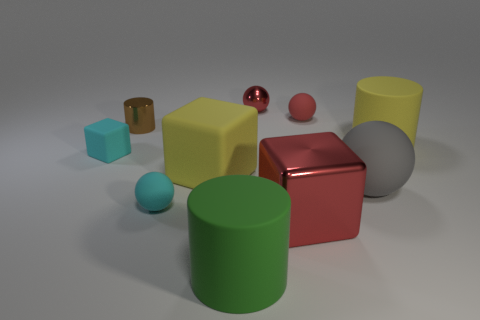There is a block that is left of the green cylinder and to the right of the cyan block; what material is it?
Give a very brief answer. Rubber. Is there anything else that is the same color as the tiny metallic ball?
Ensure brevity in your answer.  Yes. Is the number of tiny red rubber things that are to the right of the green rubber object less than the number of tiny blue shiny balls?
Keep it short and to the point. No. Is the number of cyan rubber things greater than the number of brown objects?
Keep it short and to the point. Yes. Are there any tiny red objects that are to the right of the tiny red metal thing behind the big matte cylinder that is on the right side of the big gray thing?
Ensure brevity in your answer.  Yes. How many other things are there of the same size as the cyan ball?
Your answer should be very brief. 4. There is a red metallic sphere; are there any yellow rubber objects behind it?
Offer a terse response. No. Do the tiny cube and the matte cylinder behind the green cylinder have the same color?
Provide a succinct answer. No. What color is the cylinder that is to the right of the tiny rubber ball that is to the right of the small sphere that is on the left side of the yellow cube?
Keep it short and to the point. Yellow. Are there any green matte things of the same shape as the small red rubber object?
Ensure brevity in your answer.  No. 